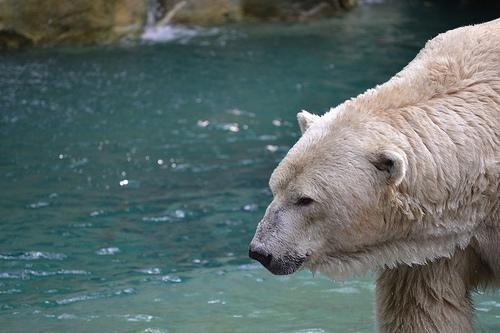Provide a brief description of the main subject and their position in the image. A polar bear standing in the water, with its furry head, black snout, and muzzle near the edge of the pool. Briefly describe the major details of the main subject and the surrounding environment. A polar bear with a black snout, black eyes, wet front leg, and furry ears stands in blue calm water, with rocks, grass, and sunlight sparkles. Mention the most remarkable features of the image, focusing on the main subject. The image showcases a polar bear with a furry head, black snout, and black eyes, standing in the water near the edge of the pool. Mention the major details of the main subject and their surroundings. A white polar bear with a black snout, eyes, and wet front leg by the edge of the water, with a small waterfall and rocks in the background. In a few words, describe the scene in the picture, emphasizing the main subject. Polar bear near calm blue water with sunlight sparkles, amidst a grassy and rocky background. Describe the focal point of the image and include some of the distinguishing/background features. A polar bear with black eyes, black snout, and wet front leg in the water, surrounded by calm waters, rocks, and grassy scenery. What are the main characteristics of the main subject in the image? Mention any background elements as well. The polar bear's main features include a black snout, black eyes, and wet white fur. There is calm water, grass, and rocks in the background. Provide a concise description of the primary subject in the image and what's happening around them. A white polar bear with wet furry neck and head stands near the water's edge, with a calm water pool and grass in the background. What is the main subject of the image and what are they doing? Mention some observable details. A large polar bear is standing in the water with its black eyes and nose, right front leg in the water and white furry ears visible. Describe the key attributes of the main subject and the background scenery. A polar bear with black eyes, snout, and muzzle, wet front leg, and furry ears stands in blue calm water surrounded by rocks, grass, and a small waterfall. 